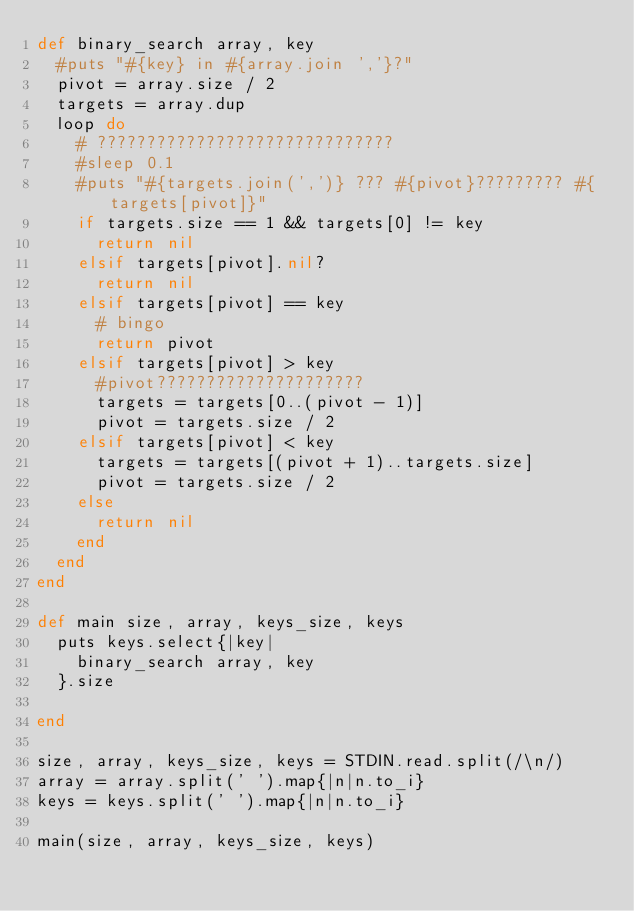<code> <loc_0><loc_0><loc_500><loc_500><_Ruby_>def binary_search array, key
  #puts "#{key} in #{array.join ','}?"
  pivot = array.size / 2
  targets = array.dup
  loop do
    # ??????????????????????????????
    #sleep 0.1
    #puts "#{targets.join(',')} ??? #{pivot}????????? #{targets[pivot]}"
    if targets.size == 1 && targets[0] != key
      return nil
    elsif targets[pivot].nil?
      return nil
    elsif targets[pivot] == key
      # bingo
      return pivot
    elsif targets[pivot] > key
      #pivot?????????????????????
      targets = targets[0..(pivot - 1)]
      pivot = targets.size / 2
    elsif targets[pivot] < key
      targets = targets[(pivot + 1)..targets.size]
      pivot = targets.size / 2
    else
      return nil
    end
  end
end

def main size, array, keys_size, keys
  puts keys.select{|key|
    binary_search array, key
  }.size

end

size, array, keys_size, keys = STDIN.read.split(/\n/)
array = array.split(' ').map{|n|n.to_i}
keys = keys.split(' ').map{|n|n.to_i}

main(size, array, keys_size, keys)</code> 